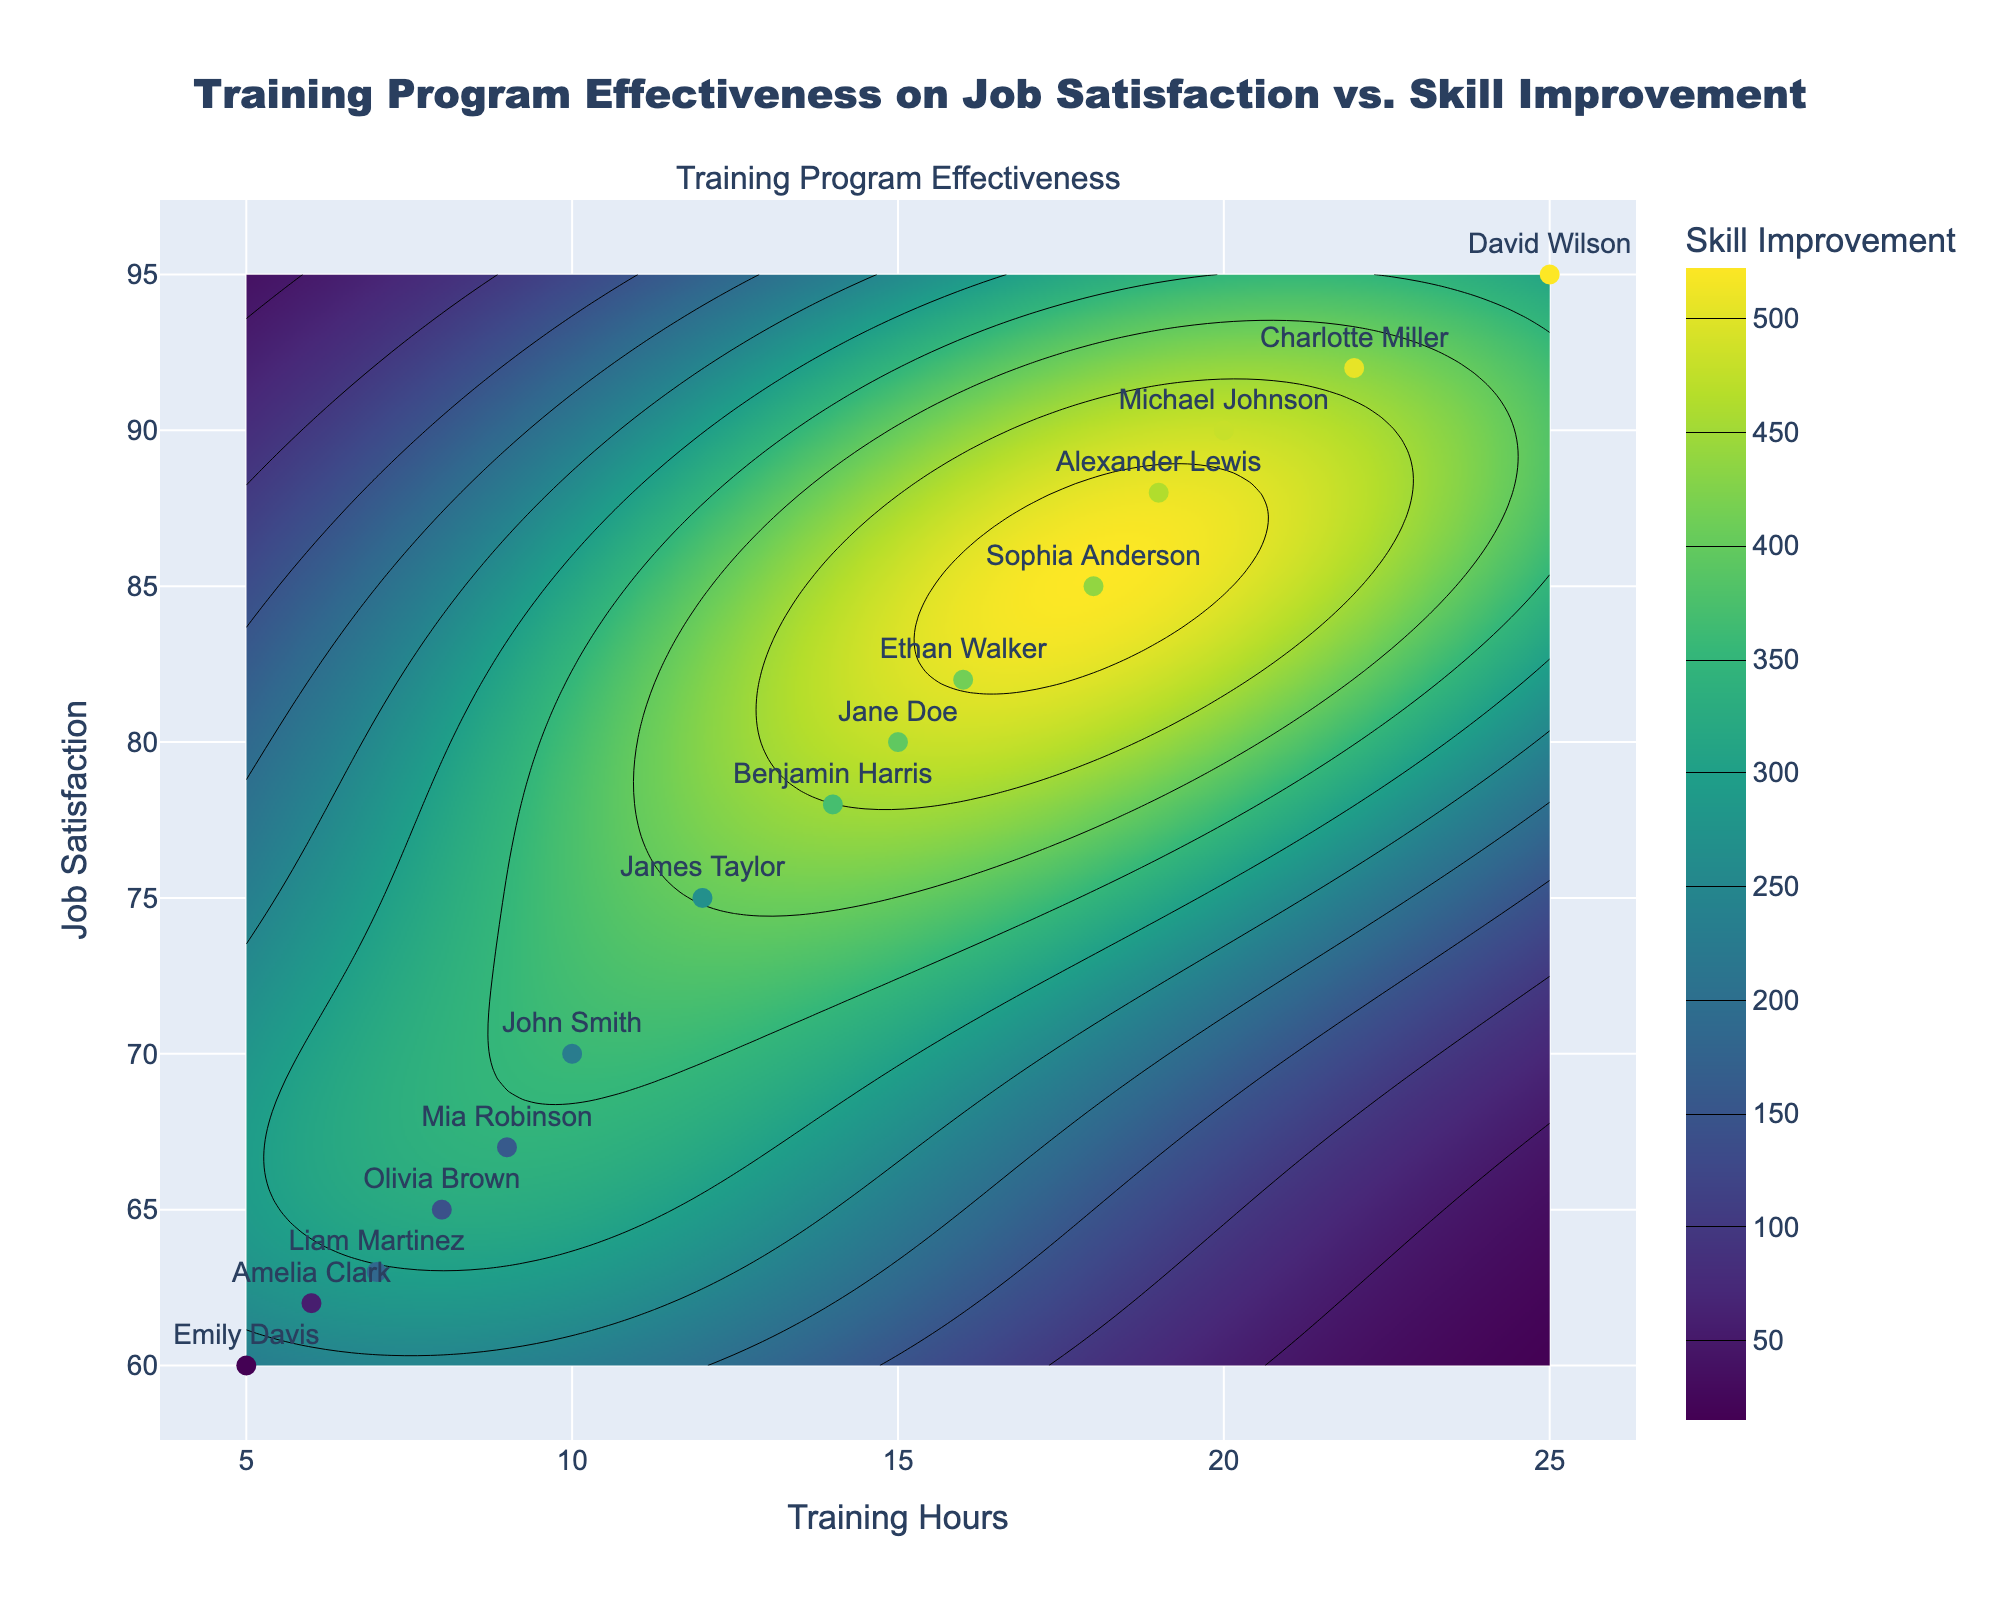How many employees are represented in the plot? Count the number of distinct employees labeled on the scatter plot.
Answer: 15 What is the range of Training Hours represented on the x-axis? Note the minimum and maximum values on the x-axis representing Training Hours.
Answer: 5 to 25 Which employee has the highest Skill Improvement, and what are their Training Hours and Job Satisfaction values? Identify the point with the highest Skill Improvement value, using the color intensity and value. Cross-reference the hover text for exact details.
Answer: David Wilson, 25 Training Hours, 95 Job Satisfaction What is the average Job Satisfaction value for employees who received more than 20 Training Hours? Identify employees with Training Hours > 20, sum their Job Satisfaction values, then divide by the number of these employees.
Answer: (92 + 95) / 2 = 93.5 Compare the Job Satisfaction of Olivia Brown and Sophia Anderson. Who has the higher value? Locate both points, then compare the corresponding Job Satisfaction values.
Answer: Sophia Anderson What is the overall trend in Job Satisfaction with increasing Training Hours? Observe the contour pattern and scatter plot, noting the general direction of change in Job Satisfaction with Training Hours.
Answer: Generally increasing Who has the lowest Job Satisfaction, and what is their corresponding Skill Improvement and Training Hours? Locate the point with the lowest Job Satisfaction value, then check the details from the hover text.
Answer: Emily Davis, 40 Skill Improvement, 5 Training Hours Based on the contour plot, within which range of Training Hours do we see the highest Skill Improvement? Examine the highest contour levels (color intensity) and note the corresponding Training Hours on the x-axis.
Answer: Around 20 to 25 How does the Skill Improvement of Ethan Walker compare to Jane Doe? Locate both points, examine their Skill Improvement values from the hover text, and compare them.
Answer: Ethan Walker's Skill Improvement is higher than Jane Doe's What's the median Job Satisfaction value among all employees? Arrange all Job Satisfaction values in ascending order and find the middle value.
Answer: 75 